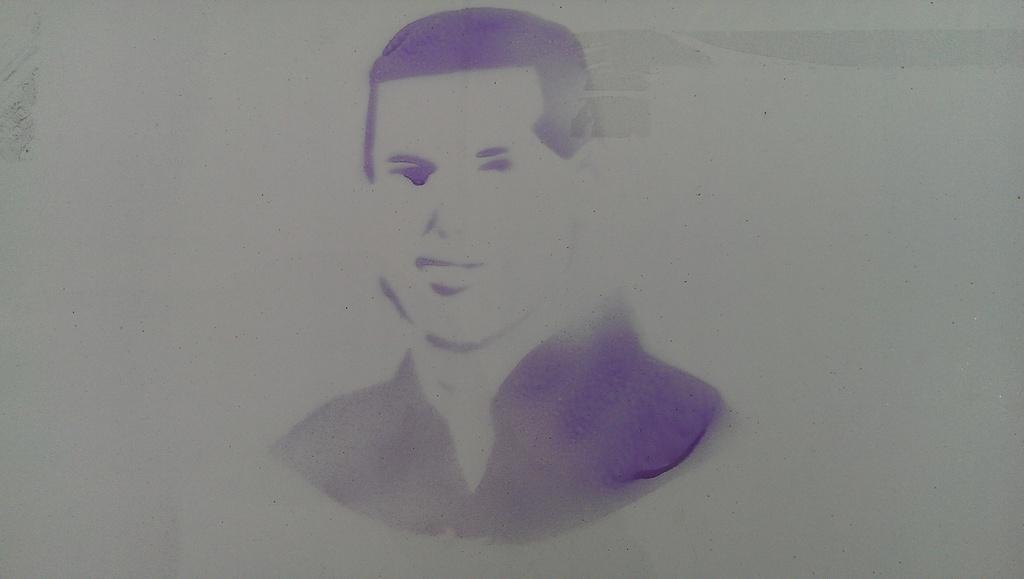How would you summarize this image in a sentence or two? In the middle of this image, there is a painting of a person in violet color. And the background is white in color. 